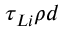Convert formula to latex. <formula><loc_0><loc_0><loc_500><loc_500>\tau _ { L i } \rho d</formula> 